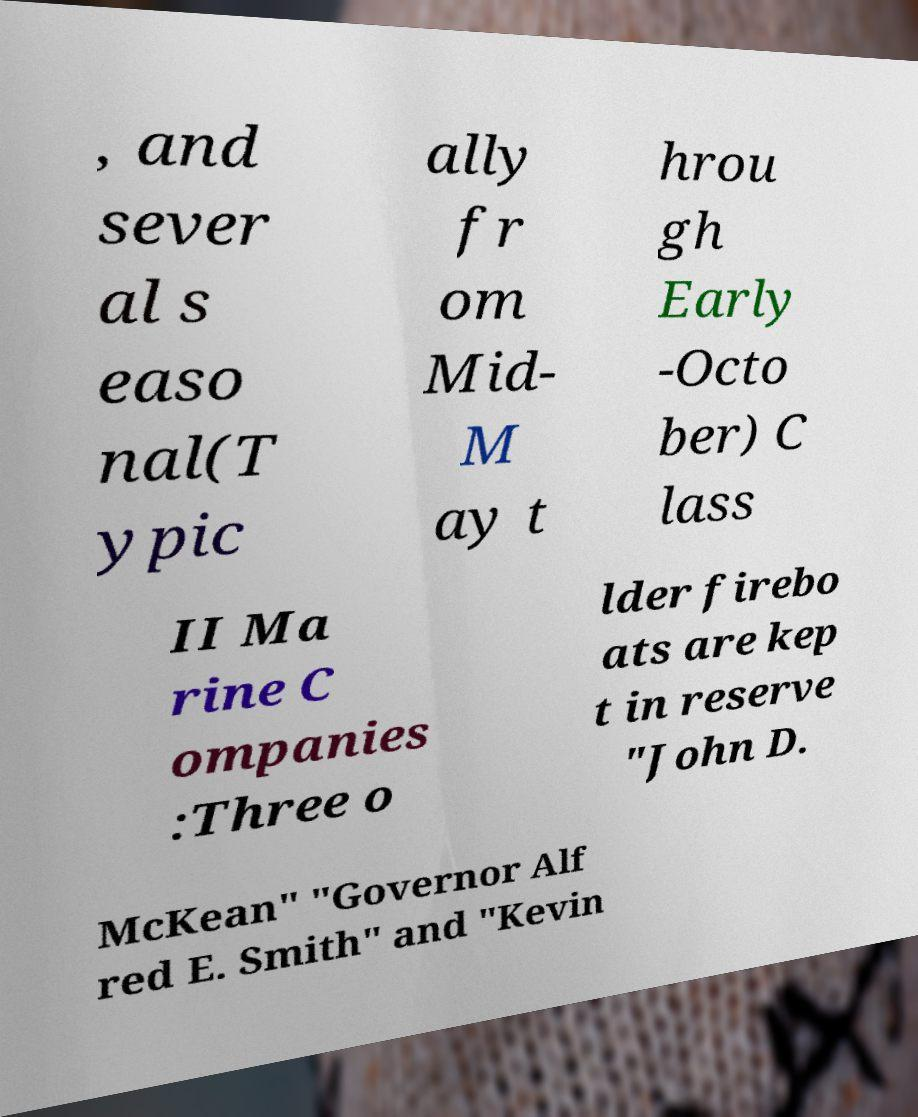Could you extract and type out the text from this image? , and sever al s easo nal(T ypic ally fr om Mid- M ay t hrou gh Early -Octo ber) C lass II Ma rine C ompanies :Three o lder firebo ats are kep t in reserve "John D. McKean" "Governor Alf red E. Smith" and "Kevin 